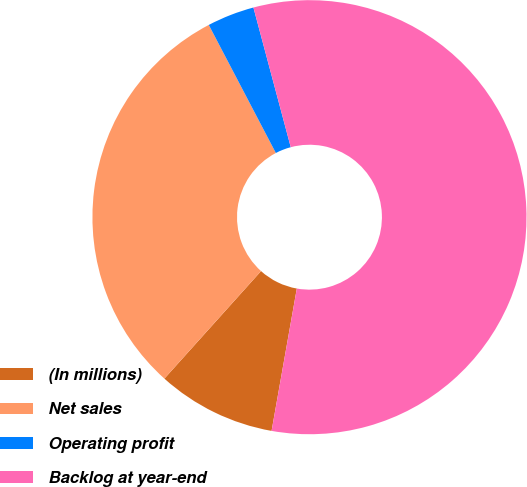Convert chart. <chart><loc_0><loc_0><loc_500><loc_500><pie_chart><fcel>(In millions)<fcel>Net sales<fcel>Operating profit<fcel>Backlog at year-end<nl><fcel>8.86%<fcel>30.67%<fcel>3.52%<fcel>56.95%<nl></chart> 